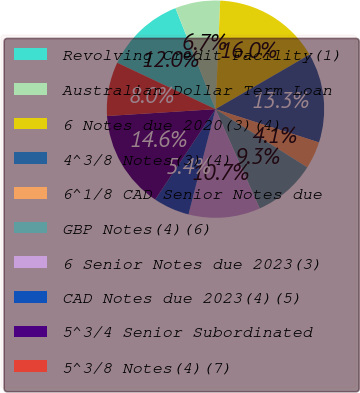Convert chart. <chart><loc_0><loc_0><loc_500><loc_500><pie_chart><fcel>Revolving Credit Facility(1)<fcel>Australian Dollar Term Loan<fcel>6 Notes due 2020(3)(4)<fcel>4^3/8 Notes(3)(4)<fcel>6^1/8 CAD Senior Notes due<fcel>GBP Notes(4)(6)<fcel>6 Senior Notes due 2023(3)<fcel>CAD Notes due 2023(4)(5)<fcel>5^3/4 Senior Subordinated<fcel>5^3/8 Notes(4)(7)<nl><fcel>11.98%<fcel>6.69%<fcel>15.95%<fcel>13.31%<fcel>4.05%<fcel>9.34%<fcel>10.66%<fcel>5.37%<fcel>14.63%<fcel>8.02%<nl></chart> 